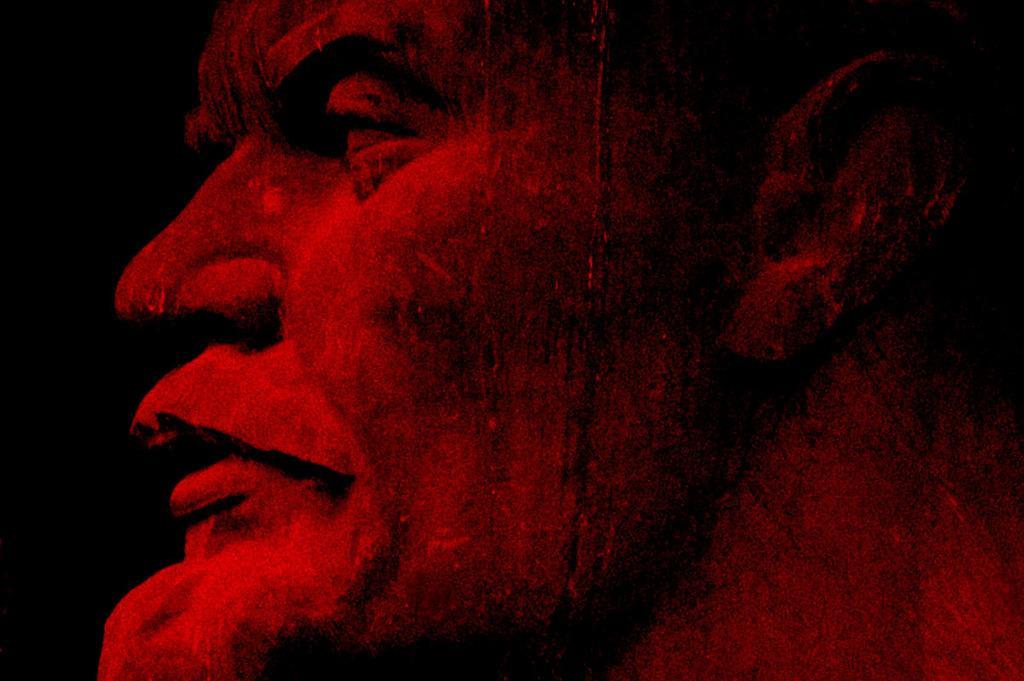Describe this image in one or two sentences. In this image we can see a depiction of a person. The background of the image is black in color. 